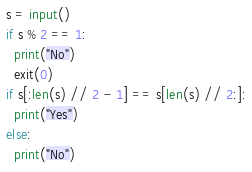<code> <loc_0><loc_0><loc_500><loc_500><_Python_>s = input()
if s % 2 == 1:
  print("No")
  exit(0)
if s[:len(s) // 2 - 1] == s[len(s) // 2:]:
  print("Yes")
else:
  print("No")</code> 